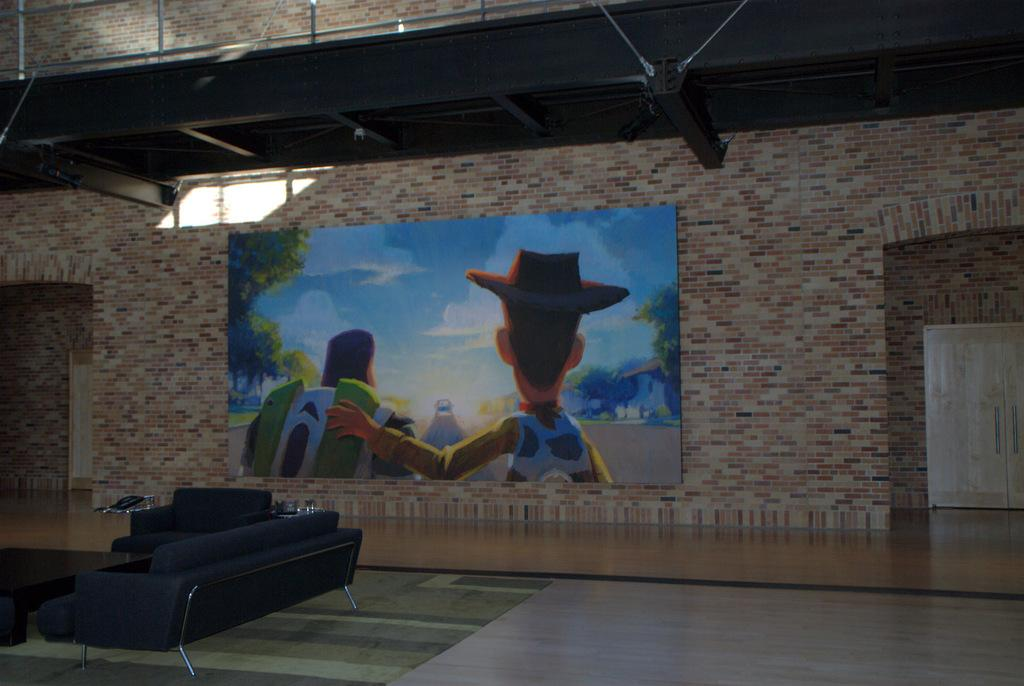What is located on the left side of the image? There is a table and sofas on the left side of the image. What can be seen on the wall in the background of the image? There is a poster on a wall in the background of the image. What type of material is visible in the image? There are metal rods visible in the image. What is the brother's name in the image? There is no reference to a brother or any individuals in the image, so it is not possible to determine their names. 